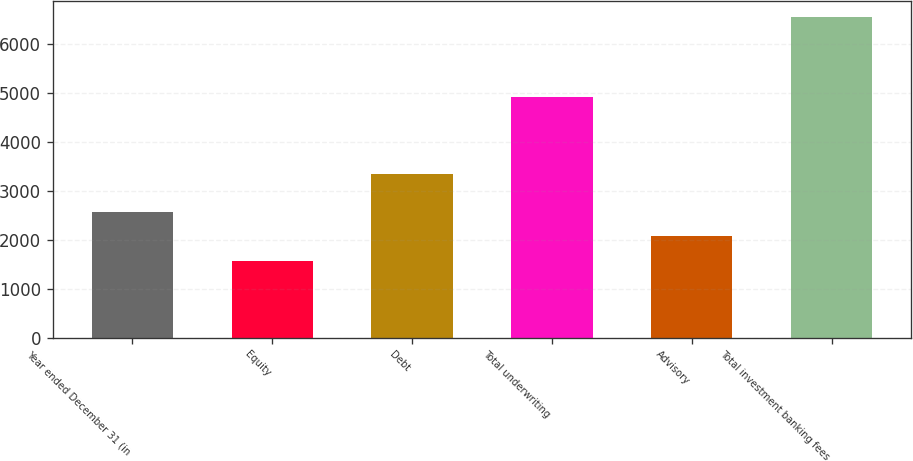<chart> <loc_0><loc_0><loc_500><loc_500><bar_chart><fcel>Year ended December 31 (in<fcel>Equity<fcel>Debt<fcel>Total underwriting<fcel>Advisory<fcel>Total investment banking fees<nl><fcel>2565.2<fcel>1571<fcel>3340<fcel>4911<fcel>2068.1<fcel>6542<nl></chart> 